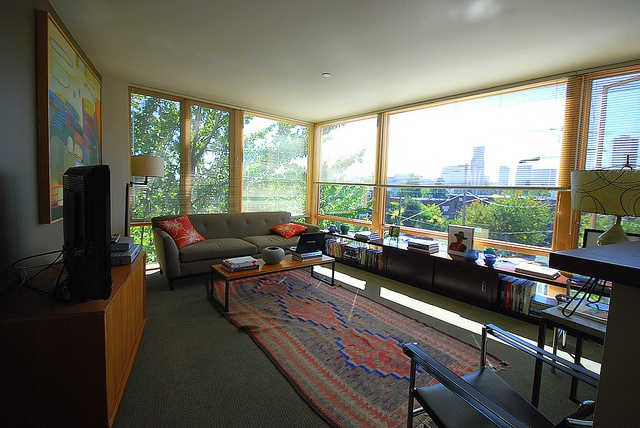Describe the objects in this image and their specific colors. I can see chair in black, gray, blue, and navy tones, couch in black, darkgreen, gray, and maroon tones, tv in black and gray tones, book in black, gray, darkgreen, and maroon tones, and laptop in black, gray, darkgreen, and darkgray tones in this image. 